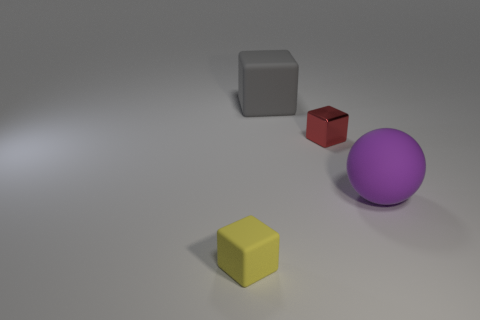Subtract all brown blocks. Subtract all yellow cylinders. How many blocks are left? 3 Add 2 tiny green metal objects. How many objects exist? 6 Subtract all spheres. How many objects are left? 3 Subtract all large metal things. Subtract all purple spheres. How many objects are left? 3 Add 3 big things. How many big things are left? 5 Add 3 tiny brown rubber cylinders. How many tiny brown rubber cylinders exist? 3 Subtract 0 cyan cylinders. How many objects are left? 4 